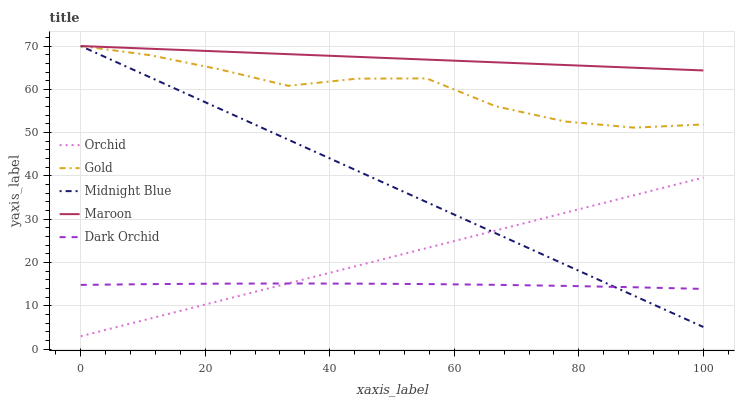Does Midnight Blue have the minimum area under the curve?
Answer yes or no. No. Does Midnight Blue have the maximum area under the curve?
Answer yes or no. No. Is Maroon the smoothest?
Answer yes or no. No. Is Maroon the roughest?
Answer yes or no. No. Does Midnight Blue have the lowest value?
Answer yes or no. No. Does Orchid have the highest value?
Answer yes or no. No. Is Orchid less than Gold?
Answer yes or no. Yes. Is Gold greater than Orchid?
Answer yes or no. Yes. Does Orchid intersect Gold?
Answer yes or no. No. 